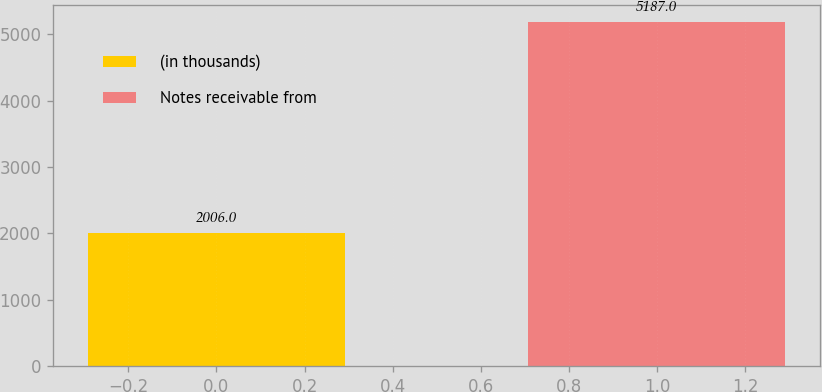Convert chart to OTSL. <chart><loc_0><loc_0><loc_500><loc_500><bar_chart><fcel>(in thousands)<fcel>Notes receivable from<nl><fcel>2006<fcel>5187<nl></chart> 